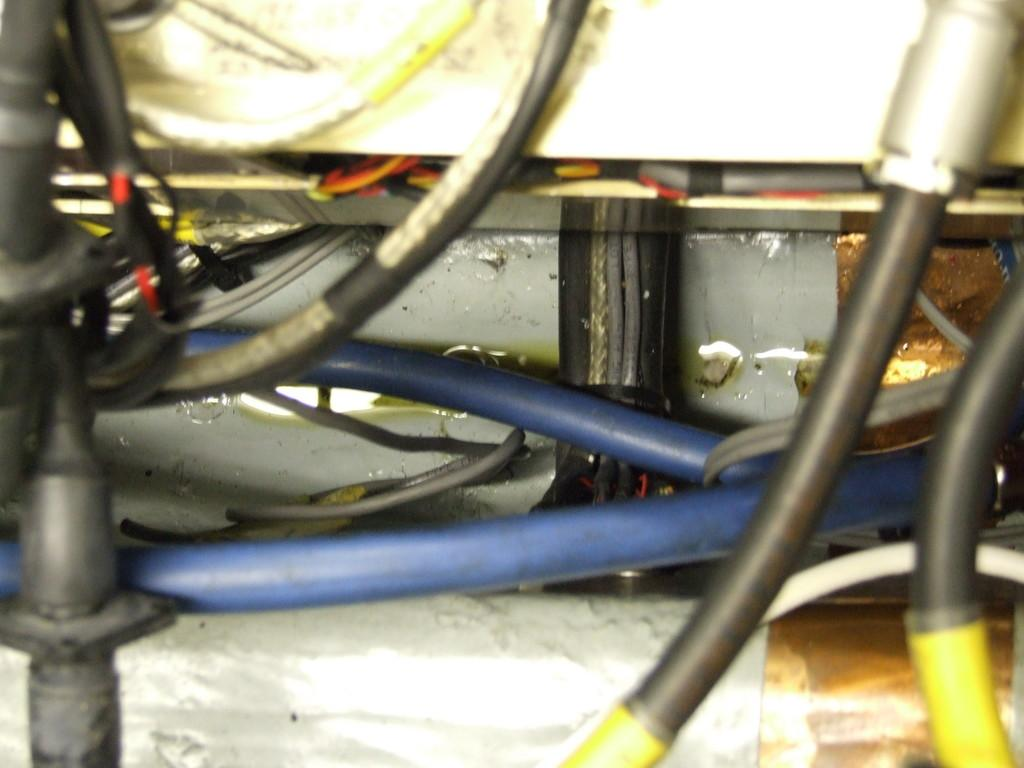What can be seen in the image? There are wires in the image. Can you describe the wires in more detail? The wires have different colors. What type of pies are being baked near the wires in the image? There are no pies or any indication of baking in the image; it only features wires with different colors. 